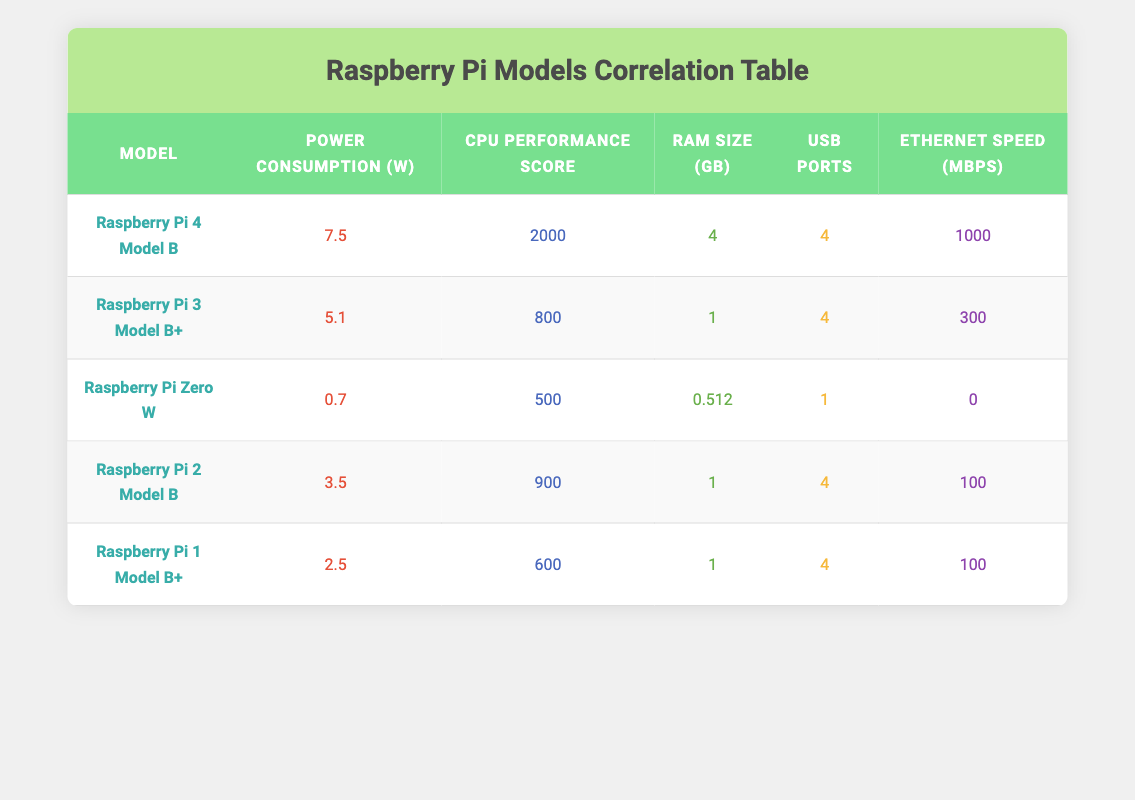What is the power consumption of the Raspberry Pi 4 Model B? Referring to the table, the power consumption of the Raspberry Pi 4 Model B is listed as 7.5 Watts.
Answer: 7.5 Watts How many USB ports does the Raspberry Pi Zero W have? Looking at the row for the Raspberry Pi Zero W in the table, it shows that it has 1 USB port.
Answer: 1 USB port What is the CPU Performance Score of the Raspberry Pi 3 Model B+? By checking the table, the CPU Performance Score for the Raspberry Pi 3 Model B+ is noted as 800.
Answer: 800 What is the average RAM size for the Raspberry Pi models listed? To find the average RAM size, we first sum the RAM sizes: 4 + 1 + 0.512 + 1 + 1 = 7.512 GB. There are 5 models, so we calculate the average as 7.512/5 = approximately 1.5024 GB.
Answer: 1.5024 GB Is the power consumption of the Raspberry Pi 2 Model B less than the Raspberry Pi 4 Model B? The power consumption of the Raspberry Pi 2 Model B is 3.5 Watts, and for the Raspberry Pi 4 Model B, it's 7.5 Watts. Since 3.5 is less than 7.5, the answer is yes.
Answer: Yes Which Raspberry Pi model has the highest Ethernet speed? Upon examining the table to compare Ethernet speeds, the Raspberry Pi 4 Model B has the highest Ethernet speed of 1000 Mbps.
Answer: Raspberry Pi 4 Model B What is the difference in CPU Performance Score between the Raspberry Pi 4 Model B and the Raspberry Pi 1 Model B+? The CPU Performance Score for the Raspberry Pi 4 Model B is 2000, and for the Raspberry Pi 1 Model B+ it is 600. The difference is 2000 - 600 = 1400.
Answer: 1400 Which models have power consumption greater than 3 Watts? By checking the power consumption column, the models with power usage greater than 3 Watts are the Raspberry Pi 4 Model B (7.5 W), Raspberry Pi 3 Model B+ (5.1 W), and Raspberry Pi 2 Model B (3.5 W).
Answer: Raspberry Pi 4 Model B, Raspberry Pi 3 Model B+, Raspberry Pi 2 Model B Is it true that all Raspberry Pi models have at least 1 USB port? The Raspberry Pi Zero W has only 1 USB port, and all other models also have at least 1 USB port. Therefore, it is true that all the listed models have at least 1 USB port.
Answer: Yes 